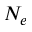Convert formula to latex. <formula><loc_0><loc_0><loc_500><loc_500>N _ { e }</formula> 